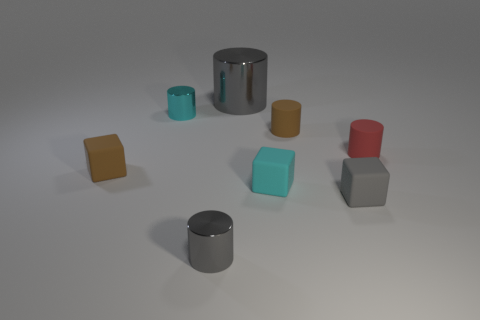What is the color of the large metal cylinder?
Ensure brevity in your answer.  Gray. There is a small gray object that is to the left of the big metallic cylinder; are there any gray things behind it?
Your response must be concise. Yes. There is a matte thing that is to the left of the small metallic thing behind the cyan matte thing; what shape is it?
Your response must be concise. Cube. Is the number of tiny brown matte cylinders less than the number of big brown cubes?
Your answer should be very brief. No. Are the large gray cylinder and the gray block made of the same material?
Give a very brief answer. No. What is the color of the tiny cylinder that is both behind the small gray cylinder and left of the cyan block?
Keep it short and to the point. Cyan. Are there any green cylinders of the same size as the red rubber cylinder?
Your answer should be compact. No. What is the size of the red cylinder right of the small gray object that is in front of the gray rubber object?
Your answer should be very brief. Small. Is the number of big gray metallic things behind the tiny gray block less than the number of metal balls?
Make the answer very short. No. The red matte cylinder is what size?
Keep it short and to the point. Small. 